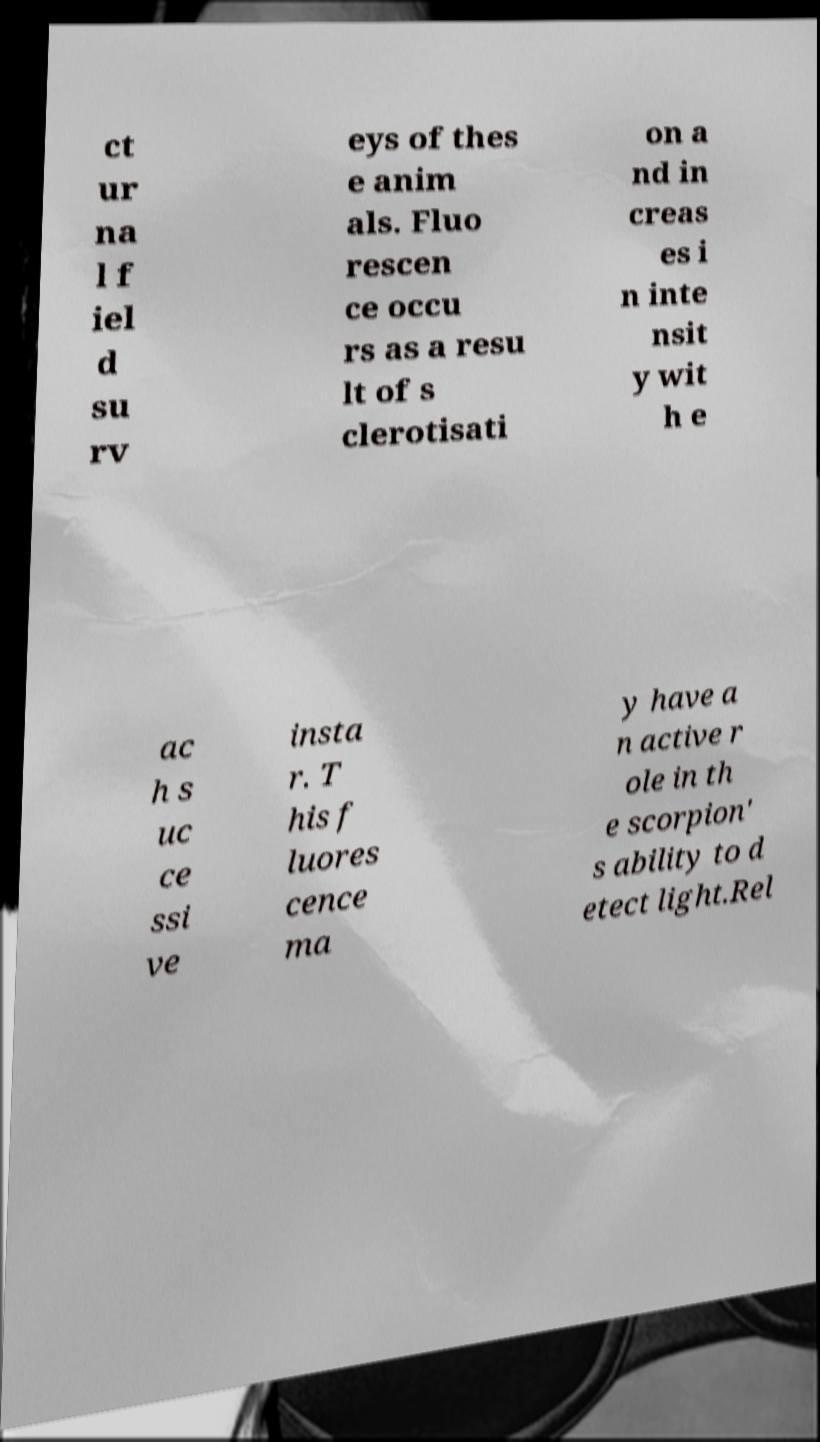Please read and relay the text visible in this image. What does it say? ct ur na l f iel d su rv eys of thes e anim als. Fluo rescen ce occu rs as a resu lt of s clerotisati on a nd in creas es i n inte nsit y wit h e ac h s uc ce ssi ve insta r. T his f luores cence ma y have a n active r ole in th e scorpion' s ability to d etect light.Rel 